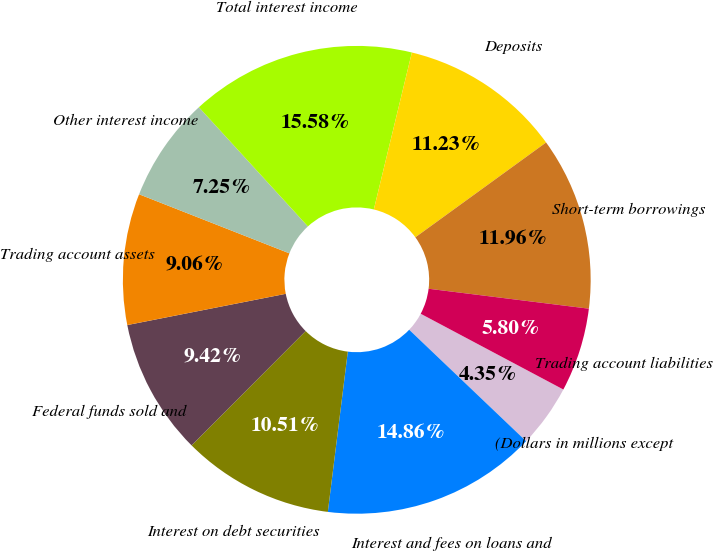Convert chart to OTSL. <chart><loc_0><loc_0><loc_500><loc_500><pie_chart><fcel>(Dollars in millions except<fcel>Interest and fees on loans and<fcel>Interest on debt securities<fcel>Federal funds sold and<fcel>Trading account assets<fcel>Other interest income<fcel>Total interest income<fcel>Deposits<fcel>Short-term borrowings<fcel>Trading account liabilities<nl><fcel>4.35%<fcel>14.86%<fcel>10.51%<fcel>9.42%<fcel>9.06%<fcel>7.25%<fcel>15.58%<fcel>11.23%<fcel>11.96%<fcel>5.8%<nl></chart> 